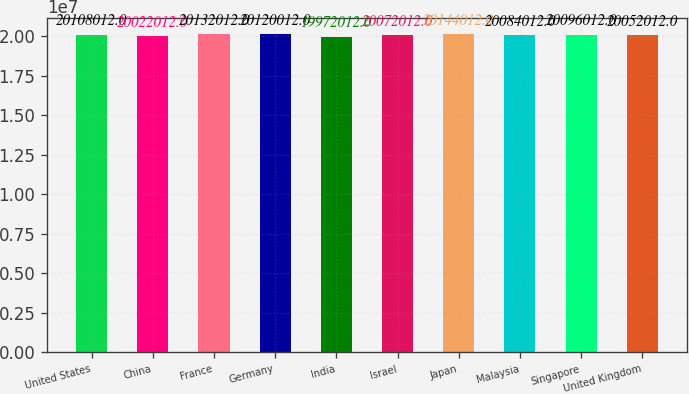<chart> <loc_0><loc_0><loc_500><loc_500><bar_chart><fcel>United States<fcel>China<fcel>France<fcel>Germany<fcel>India<fcel>Israel<fcel>Japan<fcel>Malaysia<fcel>Singapore<fcel>United Kingdom<nl><fcel>2.0108e+07<fcel>2.0022e+07<fcel>2.0132e+07<fcel>2.012e+07<fcel>1.9972e+07<fcel>2.0072e+07<fcel>2.0144e+07<fcel>2.0084e+07<fcel>2.0096e+07<fcel>2.0052e+07<nl></chart> 